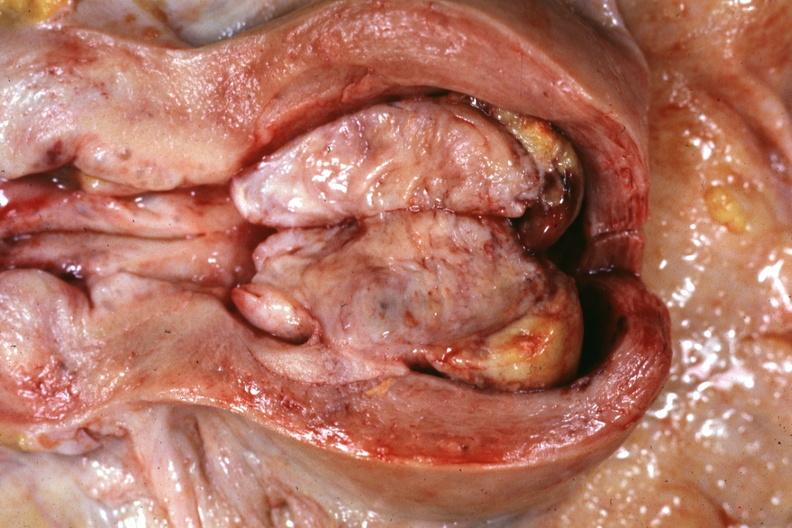does this image show opened uterus with cut surface of tumor shown very good?
Answer the question using a single word or phrase. Yes 